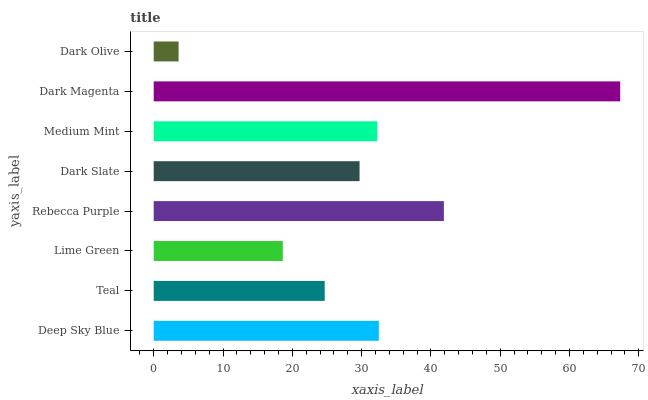Is Dark Olive the minimum?
Answer yes or no. Yes. Is Dark Magenta the maximum?
Answer yes or no. Yes. Is Teal the minimum?
Answer yes or no. No. Is Teal the maximum?
Answer yes or no. No. Is Deep Sky Blue greater than Teal?
Answer yes or no. Yes. Is Teal less than Deep Sky Blue?
Answer yes or no. Yes. Is Teal greater than Deep Sky Blue?
Answer yes or no. No. Is Deep Sky Blue less than Teal?
Answer yes or no. No. Is Medium Mint the high median?
Answer yes or no. Yes. Is Dark Slate the low median?
Answer yes or no. Yes. Is Teal the high median?
Answer yes or no. No. Is Dark Magenta the low median?
Answer yes or no. No. 